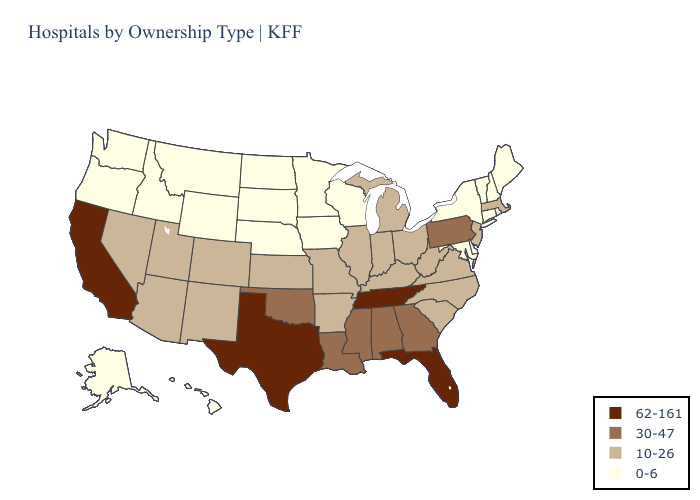Does Texas have the highest value in the USA?
Write a very short answer. Yes. Name the states that have a value in the range 30-47?
Quick response, please. Alabama, Georgia, Louisiana, Mississippi, Oklahoma, Pennsylvania. Name the states that have a value in the range 62-161?
Short answer required. California, Florida, Tennessee, Texas. What is the lowest value in the West?
Write a very short answer. 0-6. What is the value of Maine?
Concise answer only. 0-6. Is the legend a continuous bar?
Write a very short answer. No. Does the first symbol in the legend represent the smallest category?
Answer briefly. No. Which states have the lowest value in the USA?
Write a very short answer. Alaska, Connecticut, Delaware, Hawaii, Idaho, Iowa, Maine, Maryland, Minnesota, Montana, Nebraska, New Hampshire, New York, North Dakota, Oregon, Rhode Island, South Dakota, Vermont, Washington, Wisconsin, Wyoming. Does West Virginia have a lower value than Delaware?
Short answer required. No. Is the legend a continuous bar?
Answer briefly. No. What is the value of Florida?
Give a very brief answer. 62-161. Does Idaho have the lowest value in the USA?
Write a very short answer. Yes. Name the states that have a value in the range 10-26?
Be succinct. Arizona, Arkansas, Colorado, Illinois, Indiana, Kansas, Kentucky, Massachusetts, Michigan, Missouri, Nevada, New Jersey, New Mexico, North Carolina, Ohio, South Carolina, Utah, Virginia, West Virginia. Name the states that have a value in the range 10-26?
Concise answer only. Arizona, Arkansas, Colorado, Illinois, Indiana, Kansas, Kentucky, Massachusetts, Michigan, Missouri, Nevada, New Jersey, New Mexico, North Carolina, Ohio, South Carolina, Utah, Virginia, West Virginia. Name the states that have a value in the range 10-26?
Write a very short answer. Arizona, Arkansas, Colorado, Illinois, Indiana, Kansas, Kentucky, Massachusetts, Michigan, Missouri, Nevada, New Jersey, New Mexico, North Carolina, Ohio, South Carolina, Utah, Virginia, West Virginia. 